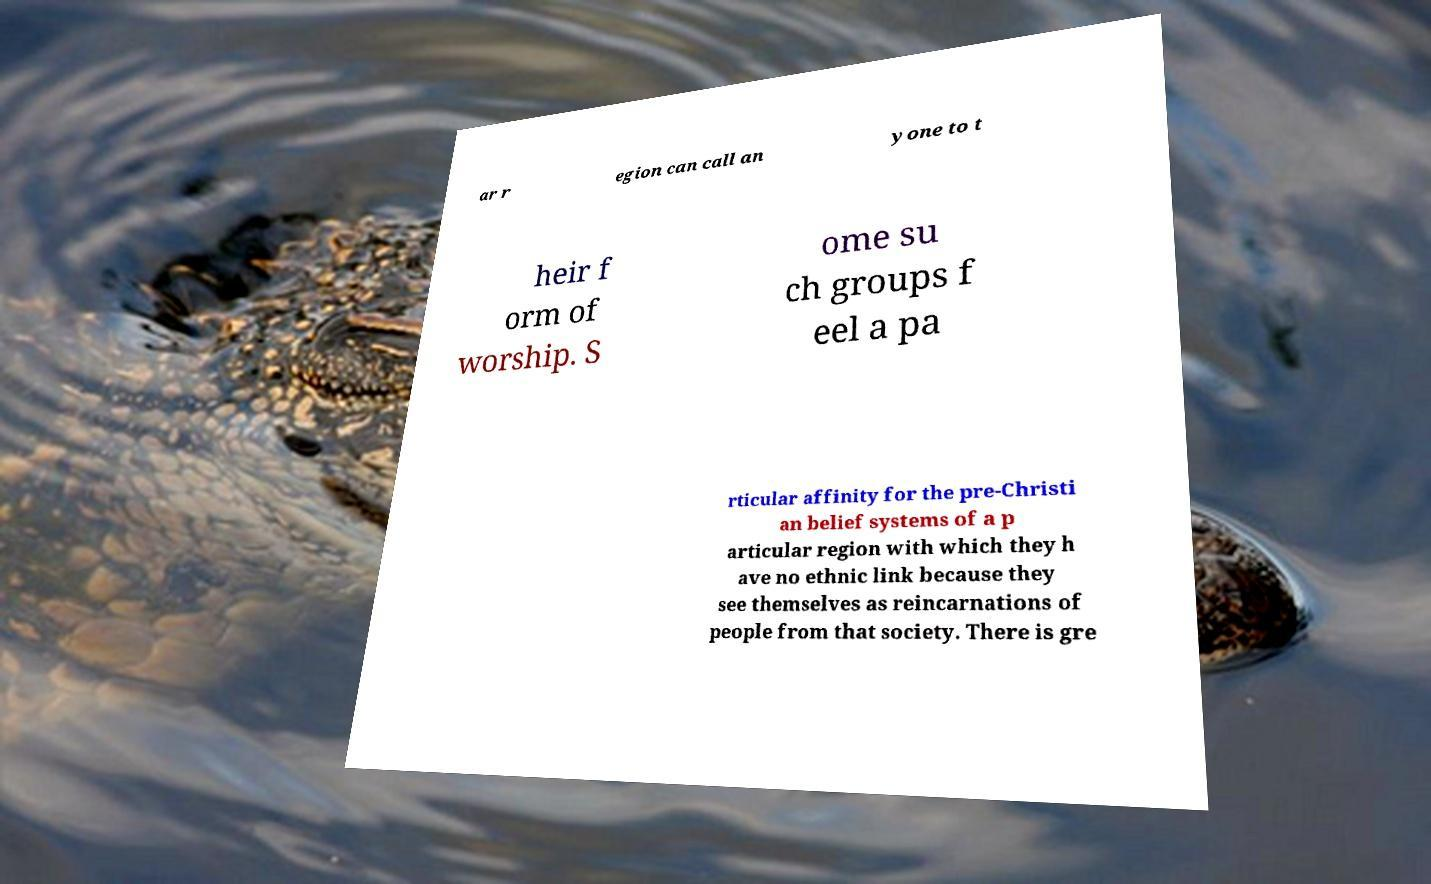I need the written content from this picture converted into text. Can you do that? ar r egion can call an yone to t heir f orm of worship. S ome su ch groups f eel a pa rticular affinity for the pre-Christi an belief systems of a p articular region with which they h ave no ethnic link because they see themselves as reincarnations of people from that society. There is gre 